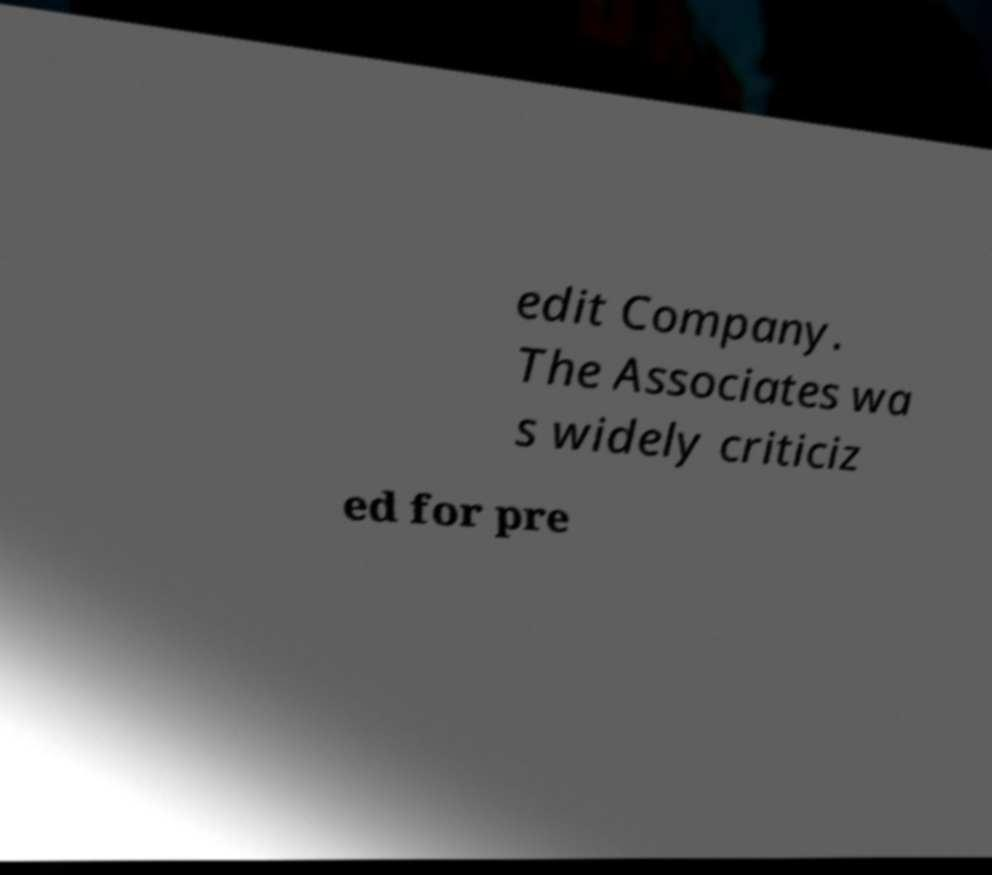Could you assist in decoding the text presented in this image and type it out clearly? edit Company. The Associates wa s widely criticiz ed for pre 